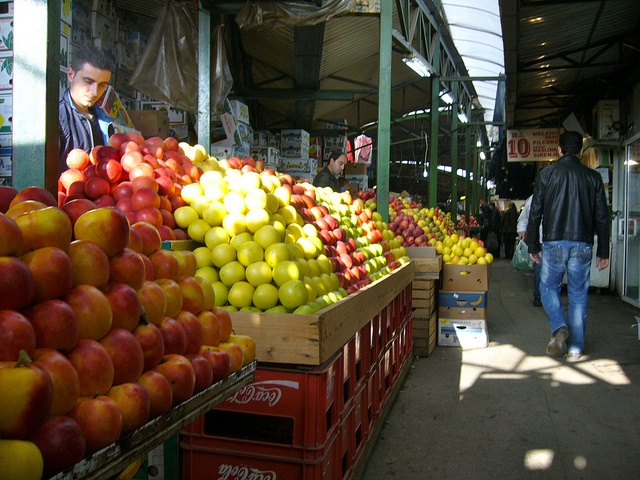Describe the objects in this image and their specific colors. I can see apple in darkgray, maroon, black, and olive tones, orange in darkgray, olive, ivory, and khaki tones, apple in darkgray, olive, ivory, and gold tones, people in darkgray, black, blue, and navy tones, and apple in darkgray, brown, maroon, salmon, and red tones in this image. 